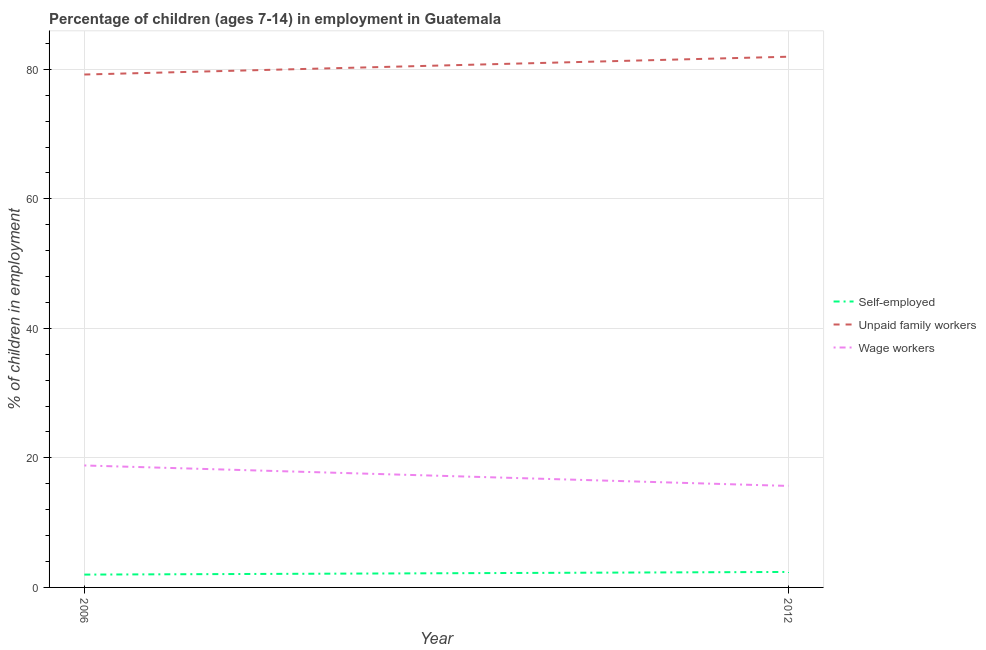Does the line corresponding to percentage of children employed as unpaid family workers intersect with the line corresponding to percentage of self employed children?
Your answer should be compact. No. Is the number of lines equal to the number of legend labels?
Your answer should be compact. Yes. What is the percentage of children employed as wage workers in 2006?
Your response must be concise. 18.83. Across all years, what is the maximum percentage of self employed children?
Offer a terse response. 2.39. Across all years, what is the minimum percentage of children employed as unpaid family workers?
Make the answer very short. 79.19. In which year was the percentage of children employed as unpaid family workers maximum?
Offer a very short reply. 2012. What is the total percentage of children employed as unpaid family workers in the graph?
Provide a succinct answer. 161.13. What is the difference between the percentage of children employed as wage workers in 2006 and that in 2012?
Provide a short and direct response. 3.16. What is the difference between the percentage of children employed as unpaid family workers in 2012 and the percentage of children employed as wage workers in 2006?
Offer a very short reply. 63.11. What is the average percentage of children employed as unpaid family workers per year?
Your answer should be very brief. 80.56. In the year 2012, what is the difference between the percentage of children employed as unpaid family workers and percentage of self employed children?
Keep it short and to the point. 79.55. In how many years, is the percentage of children employed as wage workers greater than 8 %?
Keep it short and to the point. 2. What is the ratio of the percentage of children employed as unpaid family workers in 2006 to that in 2012?
Provide a short and direct response. 0.97. Is the percentage of children employed as wage workers in 2006 less than that in 2012?
Provide a short and direct response. No. Is the percentage of children employed as unpaid family workers strictly less than the percentage of children employed as wage workers over the years?
Provide a succinct answer. No. How many lines are there?
Ensure brevity in your answer.  3. Where does the legend appear in the graph?
Keep it short and to the point. Center right. What is the title of the graph?
Make the answer very short. Percentage of children (ages 7-14) in employment in Guatemala. Does "Manufactures" appear as one of the legend labels in the graph?
Ensure brevity in your answer.  No. What is the label or title of the X-axis?
Make the answer very short. Year. What is the label or title of the Y-axis?
Make the answer very short. % of children in employment. What is the % of children in employment in Self-employed in 2006?
Offer a terse response. 1.98. What is the % of children in employment of Unpaid family workers in 2006?
Your answer should be compact. 79.19. What is the % of children in employment in Wage workers in 2006?
Make the answer very short. 18.83. What is the % of children in employment of Self-employed in 2012?
Make the answer very short. 2.39. What is the % of children in employment in Unpaid family workers in 2012?
Your answer should be very brief. 81.94. What is the % of children in employment in Wage workers in 2012?
Ensure brevity in your answer.  15.67. Across all years, what is the maximum % of children in employment of Self-employed?
Your answer should be very brief. 2.39. Across all years, what is the maximum % of children in employment of Unpaid family workers?
Provide a short and direct response. 81.94. Across all years, what is the maximum % of children in employment of Wage workers?
Ensure brevity in your answer.  18.83. Across all years, what is the minimum % of children in employment of Self-employed?
Offer a terse response. 1.98. Across all years, what is the minimum % of children in employment in Unpaid family workers?
Offer a terse response. 79.19. Across all years, what is the minimum % of children in employment in Wage workers?
Your answer should be compact. 15.67. What is the total % of children in employment in Self-employed in the graph?
Your answer should be very brief. 4.37. What is the total % of children in employment of Unpaid family workers in the graph?
Keep it short and to the point. 161.13. What is the total % of children in employment in Wage workers in the graph?
Give a very brief answer. 34.5. What is the difference between the % of children in employment of Self-employed in 2006 and that in 2012?
Make the answer very short. -0.41. What is the difference between the % of children in employment in Unpaid family workers in 2006 and that in 2012?
Give a very brief answer. -2.75. What is the difference between the % of children in employment in Wage workers in 2006 and that in 2012?
Make the answer very short. 3.16. What is the difference between the % of children in employment in Self-employed in 2006 and the % of children in employment in Unpaid family workers in 2012?
Offer a terse response. -79.96. What is the difference between the % of children in employment of Self-employed in 2006 and the % of children in employment of Wage workers in 2012?
Your answer should be compact. -13.69. What is the difference between the % of children in employment of Unpaid family workers in 2006 and the % of children in employment of Wage workers in 2012?
Offer a very short reply. 63.52. What is the average % of children in employment of Self-employed per year?
Offer a very short reply. 2.19. What is the average % of children in employment of Unpaid family workers per year?
Your answer should be very brief. 80.56. What is the average % of children in employment in Wage workers per year?
Offer a terse response. 17.25. In the year 2006, what is the difference between the % of children in employment of Self-employed and % of children in employment of Unpaid family workers?
Provide a succinct answer. -77.21. In the year 2006, what is the difference between the % of children in employment of Self-employed and % of children in employment of Wage workers?
Make the answer very short. -16.85. In the year 2006, what is the difference between the % of children in employment in Unpaid family workers and % of children in employment in Wage workers?
Offer a very short reply. 60.36. In the year 2012, what is the difference between the % of children in employment of Self-employed and % of children in employment of Unpaid family workers?
Offer a terse response. -79.55. In the year 2012, what is the difference between the % of children in employment in Self-employed and % of children in employment in Wage workers?
Provide a short and direct response. -13.28. In the year 2012, what is the difference between the % of children in employment in Unpaid family workers and % of children in employment in Wage workers?
Your response must be concise. 66.27. What is the ratio of the % of children in employment in Self-employed in 2006 to that in 2012?
Offer a very short reply. 0.83. What is the ratio of the % of children in employment in Unpaid family workers in 2006 to that in 2012?
Offer a very short reply. 0.97. What is the ratio of the % of children in employment in Wage workers in 2006 to that in 2012?
Keep it short and to the point. 1.2. What is the difference between the highest and the second highest % of children in employment in Self-employed?
Give a very brief answer. 0.41. What is the difference between the highest and the second highest % of children in employment of Unpaid family workers?
Offer a very short reply. 2.75. What is the difference between the highest and the second highest % of children in employment in Wage workers?
Give a very brief answer. 3.16. What is the difference between the highest and the lowest % of children in employment of Self-employed?
Give a very brief answer. 0.41. What is the difference between the highest and the lowest % of children in employment of Unpaid family workers?
Give a very brief answer. 2.75. What is the difference between the highest and the lowest % of children in employment in Wage workers?
Offer a terse response. 3.16. 